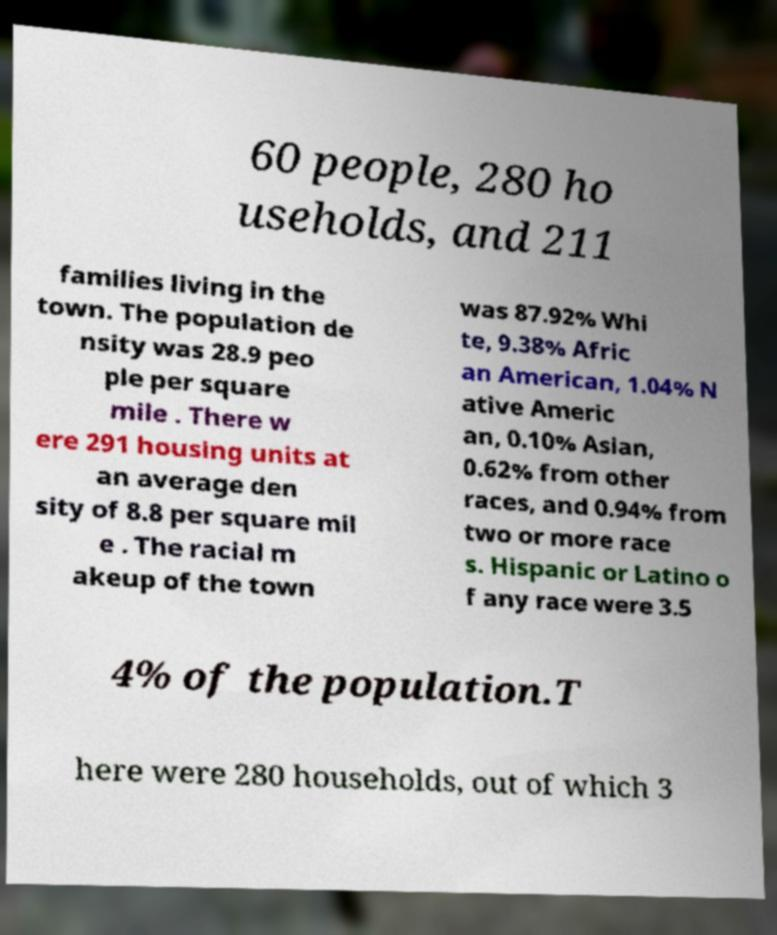I need the written content from this picture converted into text. Can you do that? 60 people, 280 ho useholds, and 211 families living in the town. The population de nsity was 28.9 peo ple per square mile . There w ere 291 housing units at an average den sity of 8.8 per square mil e . The racial m akeup of the town was 87.92% Whi te, 9.38% Afric an American, 1.04% N ative Americ an, 0.10% Asian, 0.62% from other races, and 0.94% from two or more race s. Hispanic or Latino o f any race were 3.5 4% of the population.T here were 280 households, out of which 3 